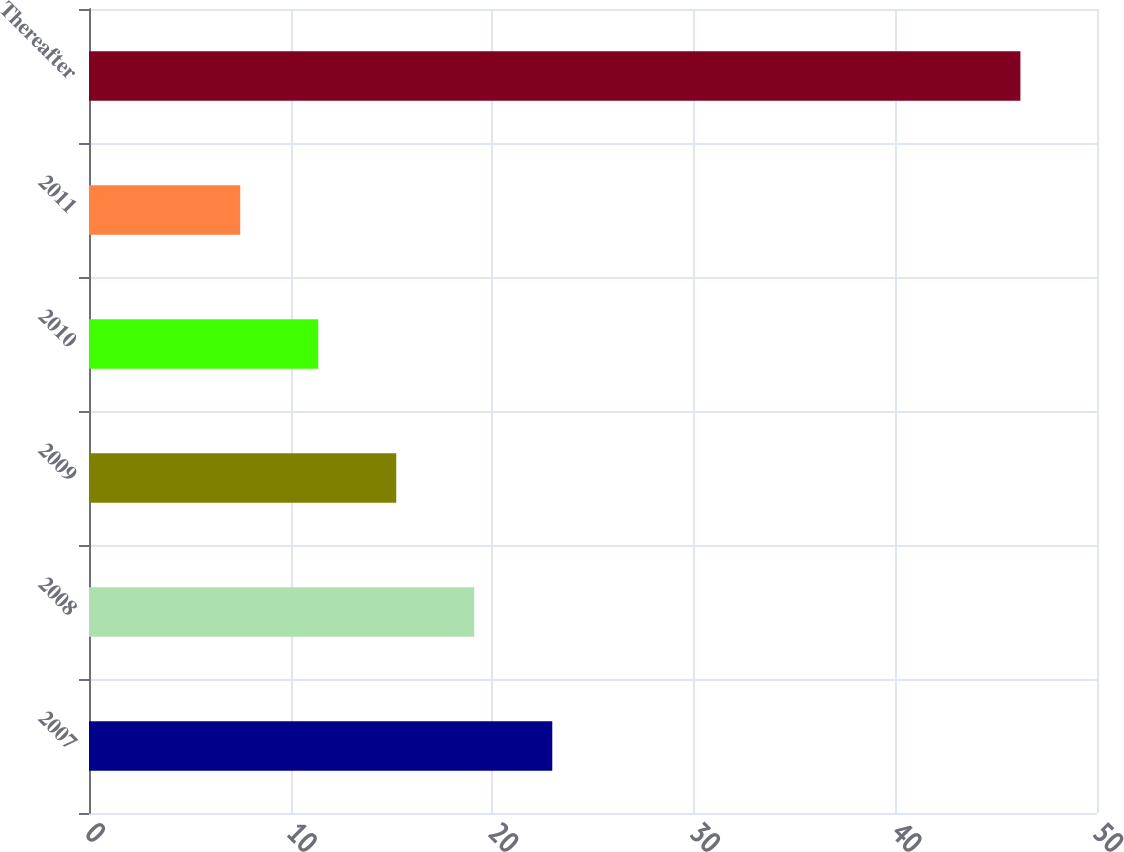Convert chart. <chart><loc_0><loc_0><loc_500><loc_500><bar_chart><fcel>2007<fcel>2008<fcel>2009<fcel>2010<fcel>2011<fcel>Thereafter<nl><fcel>22.98<fcel>19.11<fcel>15.24<fcel>11.37<fcel>7.5<fcel>46.2<nl></chart> 